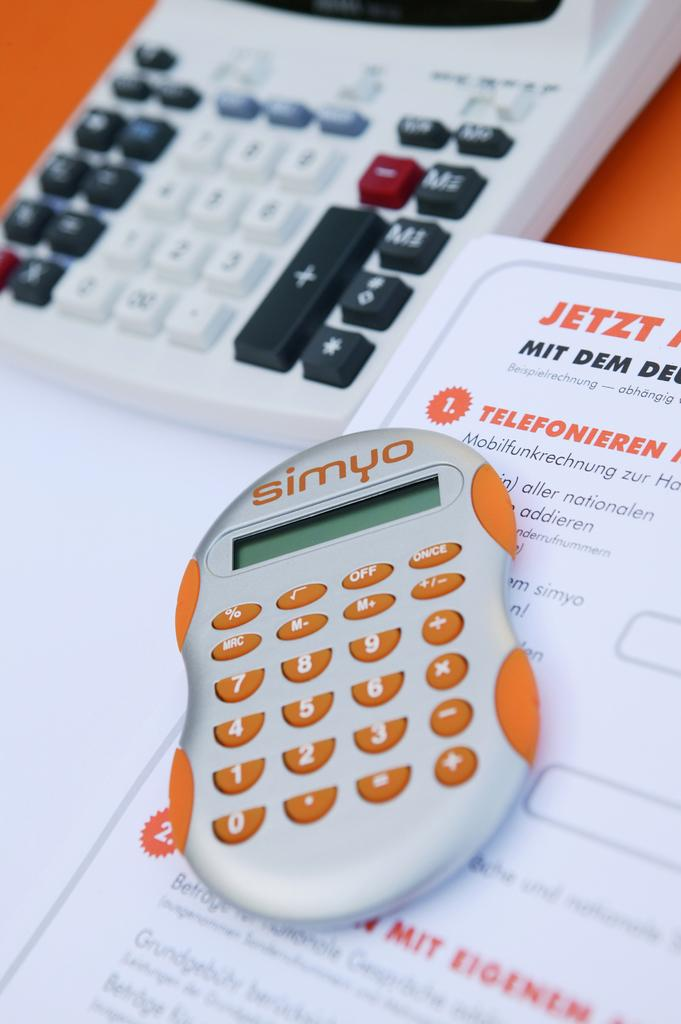<image>
Summarize the visual content of the image. A white calculator with yellow keys that reads, "Simyo" sits next to a large calculator. 